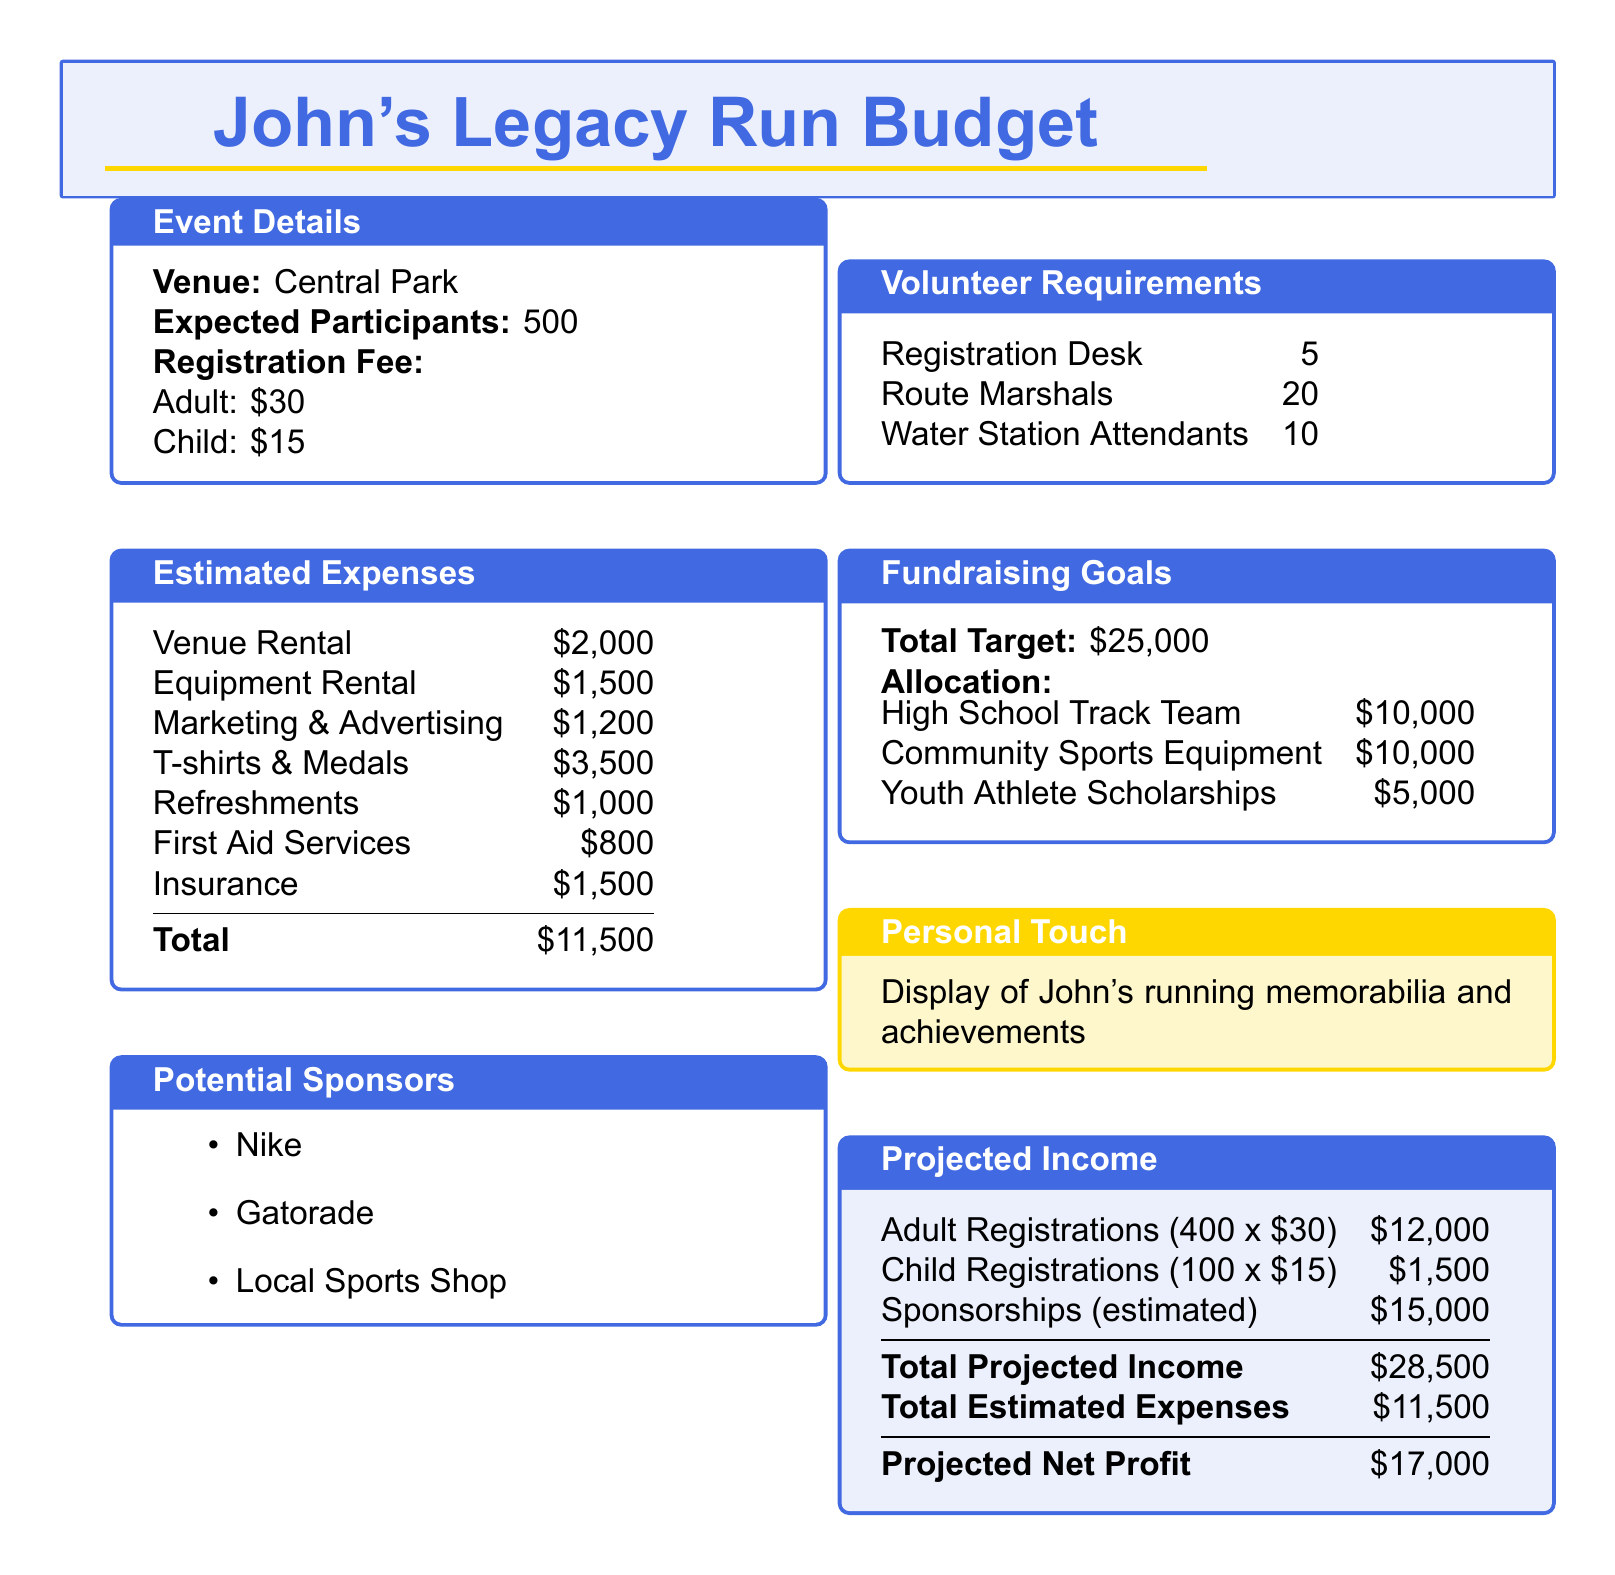What is the expected number of participants? The document states the expected number of participants for the event is 500.
Answer: 500 What is the registration fee for children? The document specifies that the registration fee for children is $15.
Answer: $15 What is the total estimated expenses? The document outlines that the total estimated expenses for the event add up to $11,500.
Answer: $11,500 What is the total fundraising target? The document indicates that the total fundraising target is $25,000.
Answer: $25,000 How much is allocated for the High School Track Team? The document indicates that $10,000 is allocated for the High School Track Team.
Answer: $10,000 What is the total projected income? According to the document, the total projected income is $28,500.
Answer: $28,500 How many route marshals are required? The document specifies that 20 route marshals are needed for the event.
Answer: 20 What is the projected net profit? The document calculates the projected net profit to be $17,000.
Answer: $17,000 Which company is listed as a potential sponsor? The document lists Nike as one of the potential sponsors.
Answer: Nike 